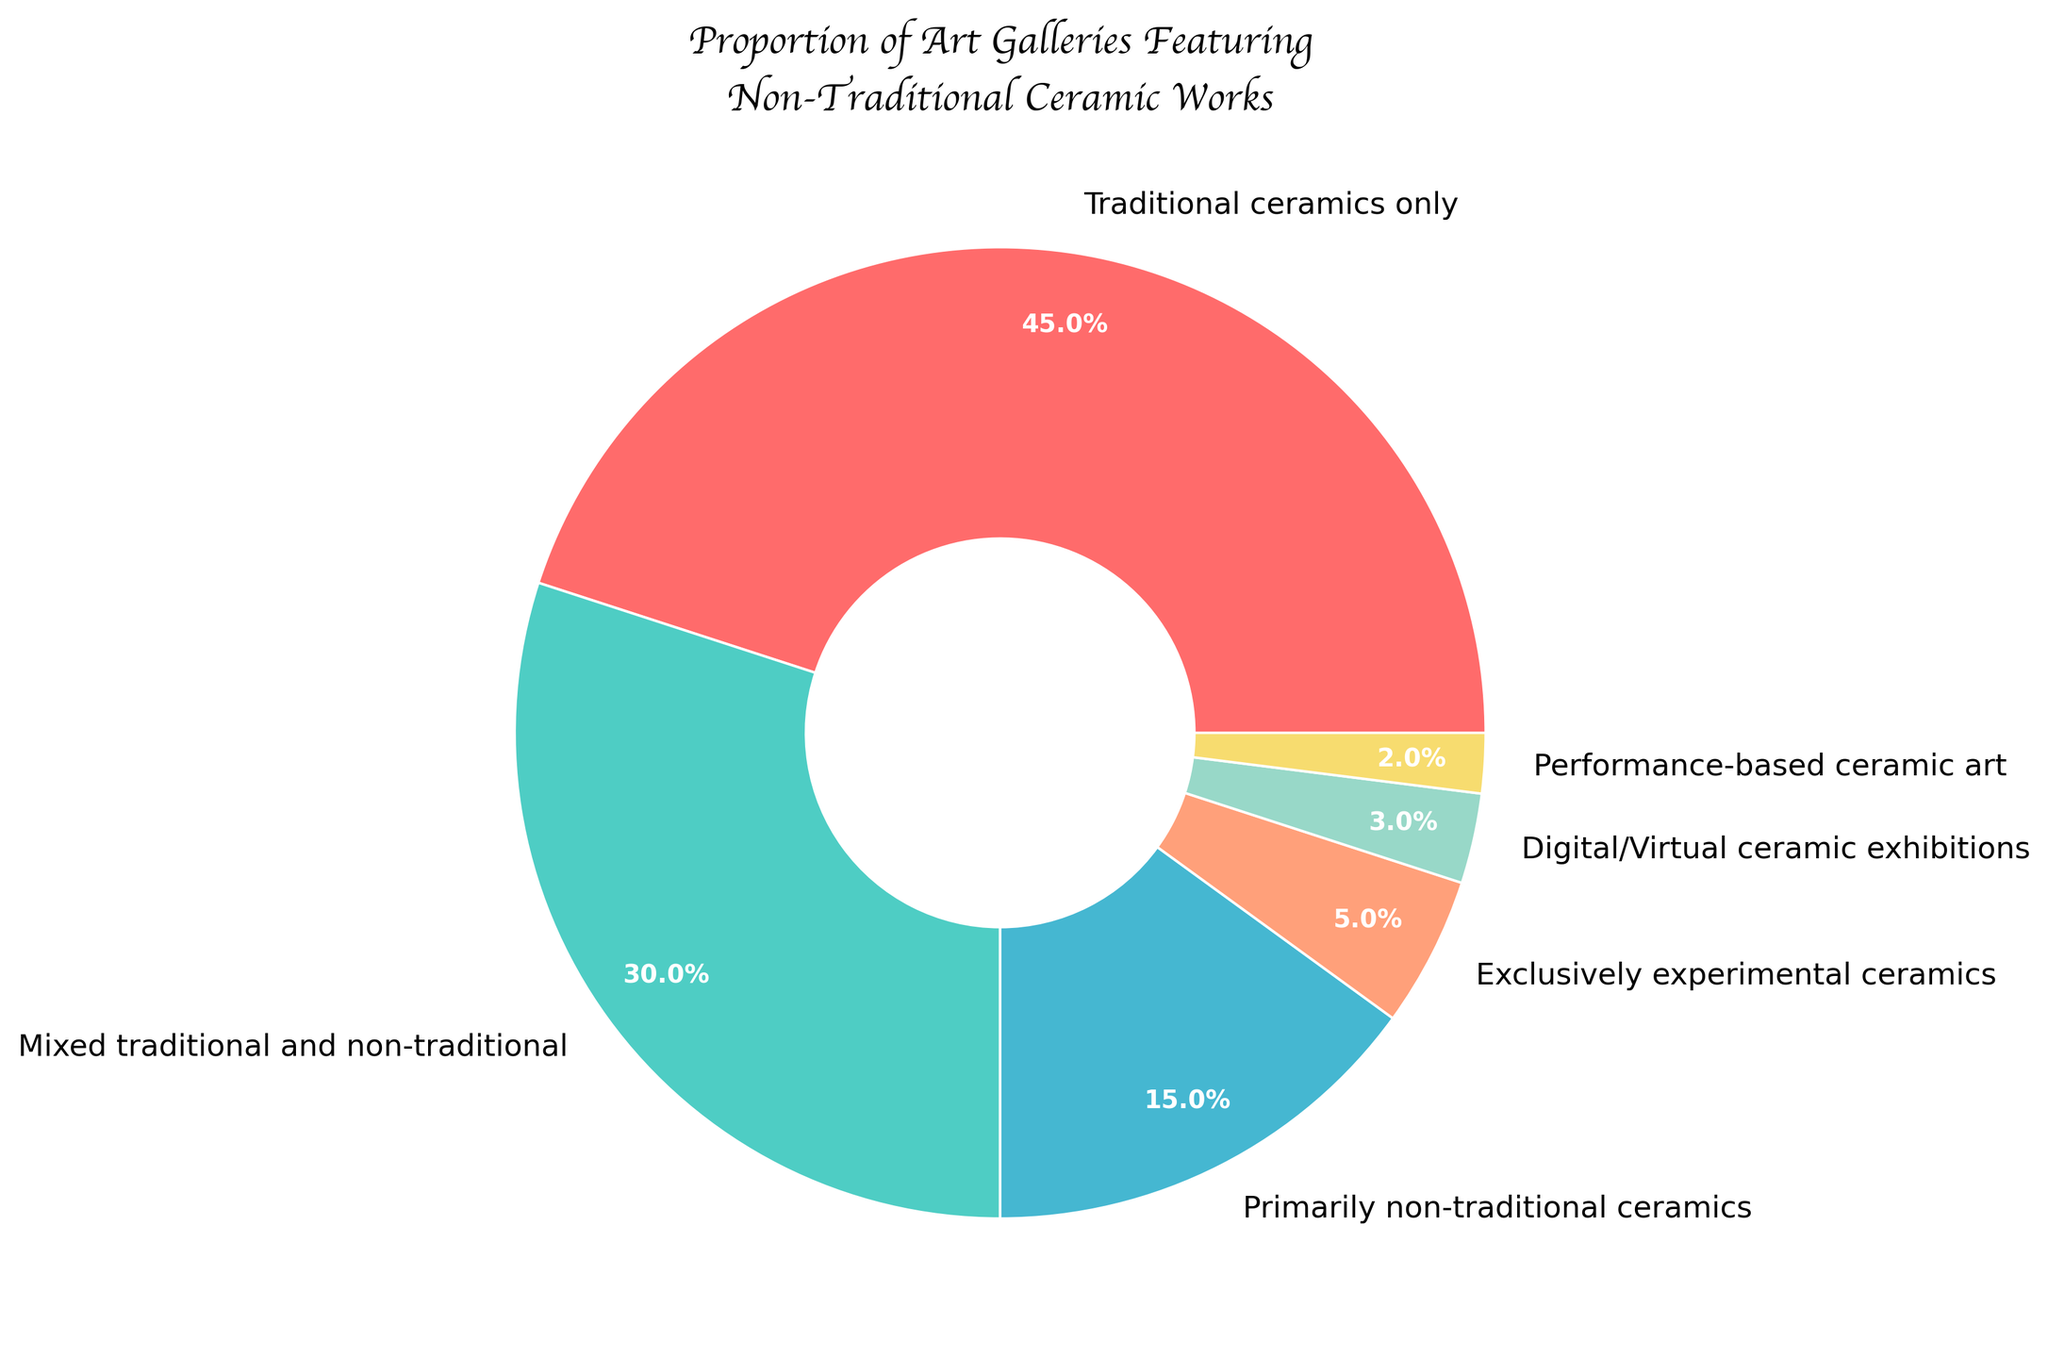Which category has the largest proportion of art galleries? The largest slice of the pie chart is labeled "Traditional ceramics only" and it shows 45%, which is the largest proportion.
Answer: Traditional ceramics only What percentage of galleries feature non-traditional ceramics, either exclusively or primarily? Add the percentage of "Primarily non-traditional ceramics" (15%) to the percentage of "Exclusively experimental ceramics" (5%). So, 15% + 5% = 20%.
Answer: 20% How many more galleries feature traditional ceramics only compared to those that feature performance-based ceramic art? Subtract the percentage of "Performance-based ceramic art" (2%) from "Traditional ceramics only" (45%). So, 45% - 2% = 43%.
Answer: 43% Which categories combined make up less than 10% of the galleries? The categories "Digital/Virtual ceramic exhibitions" (3%) and "Performance-based ceramic art" (2%) sum to 3% + 2% = 5%. Both these categories individually and combined make up less than 10%.
Answer: Digital/Virtual ceramic exhibitions, Performance-based ceramic art What is the total percentage of galleries that include non-traditional ceramics in some form (mixed, primarily non-traditional, exclusively experimental, digital/virtual, or performance-based)? Add the percentages for "Mixed traditional and non-traditional" (30%), "Primarily non-traditional ceramics" (15%), "Exclusively experimental ceramics" (5%), "Digital/Virtual ceramic exhibitions" (3%), and "Performance-based ceramic art" (2%). So, 30% + 15% + 5% + 3% + 2% = 55%.
Answer: 55% What is the difference in percentage between galleries that feature exclusively experimental ceramics and those that feature a mix of traditional and non-traditional ceramics? Subtract the percentage of "Exclusively experimental ceramics" (5%) from "Mixed traditional and non-traditional ceramics" (30%). So, 30% - 5% = 25%.
Answer: 25% If you add the galleries featuring exclusively experimental ceramics and digital/virtual ceramic exhibitions, what is their combined percentage? Add the percentage of "Exclusively experimental ceramics" (5%) to the percentage of "Digital/Virtual ceramic exhibitions" (3%). So, 5% + 3% = 8%.
Answer: 8% Which category is represented by the green section in the pie chart? The green section of the pie chart represents "Mixed traditional and non-traditional" ceramics.
Answer: Mixed traditional and non-traditional What is the total percentage of galleries that feature performance-based ceramic art, either exclusively or mixed? The pie chart shows that only the "Performance-based ceramic art" section exists for this kind of art, with 2%. There is no mixed category specific for performance-based ceramics indicated separately.
Answer: 2% 